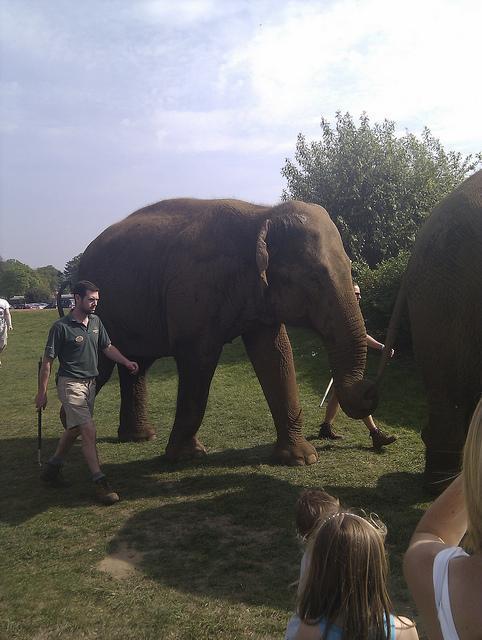What is the woman in white shirt likely to be doing?
Choose the correct response, then elucidate: 'Answer: answer
Rationale: rationale.'
Options: Covering face, feeding, taking photo, waving. Answer: taking photo.
Rationale: The woman is taking a picture of the elephant. 